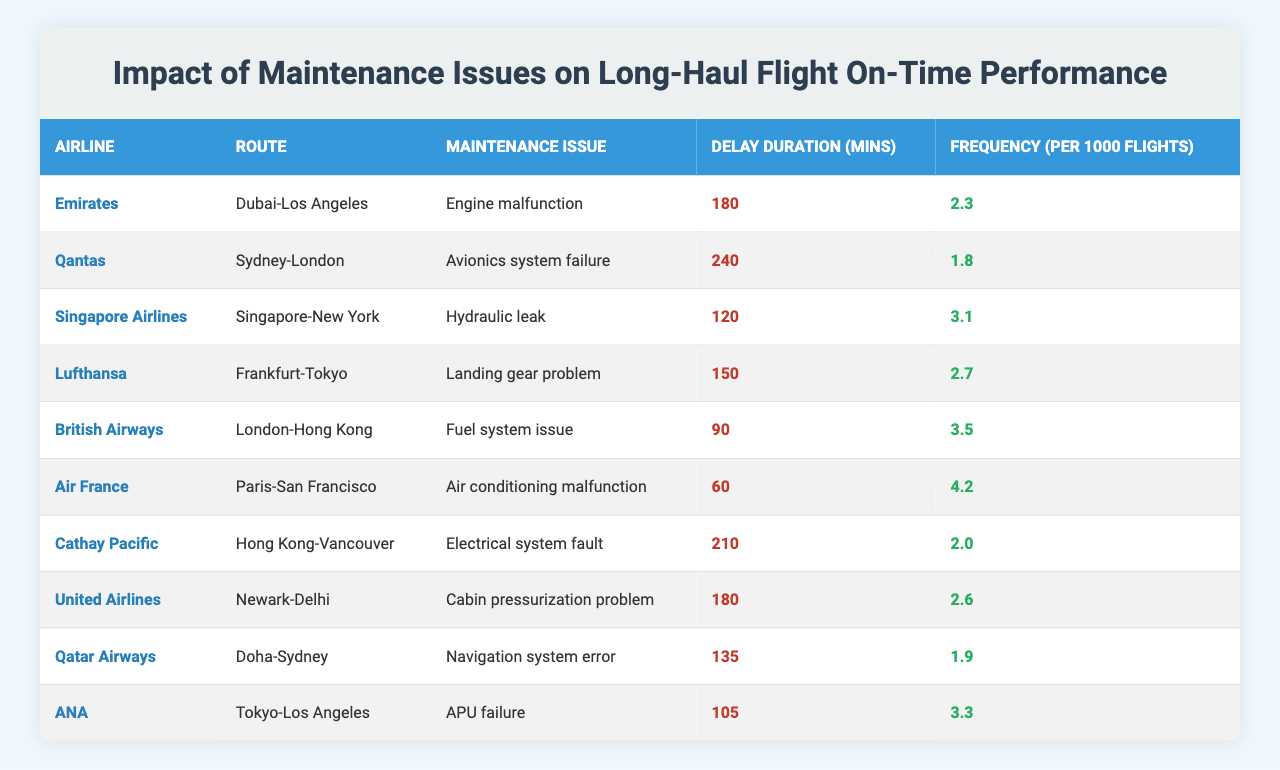What is the longest delay duration in the table? The maximum delay duration can be found by comparing all the values in the "Delay Duration (mins)" column. The maximum value is 240 minutes, which corresponds to Qantas.
Answer: 240 Which airline has the most frequent maintenance issue based on the table? To determine the most frequent maintenance issue, compare the "Frequency (per 1000 flights)" values. The highest value is 4.2 for Air France.
Answer: Air France How many maintenance issues contributed to delays longer than 150 minutes? Count the number of entries in the "Delay Duration (mins)" column that are greater than 150 minutes. The entries for Qantas (240), Emirates (180), and United Airlines (180) contribute to this, totaling three.
Answer: 3 Is there any airline listed that has a fuel system issue? Check the "Maintenance Issue" column for the presence of "Fuel system issue." British Airways has this maintenance issue.
Answer: Yes What is the average delay duration for the airlines in the table? To calculate the average delay, sum all the "Delay Duration (mins)" values (180+240+120+150+90+60+210+180+135+105) to get 1,470 minutes and divide by the number of records (10). Therefore, the average is 1,470/10 = 147 minutes.
Answer: 147 Which airline has the least frequency of maintenance issues recorded? Compare the "Frequency (per 1000 flights)" values to find the lowest. The Aviation issue of Cathay Pacific has the lowest frequency at 2.0.
Answer: Cathay Pacific Are maintenance issues more likely to cause delays above 150 minutes for Emirates compared to others? Check Emirates' delay entry (180 minutes) and compare it with others. Since two other airlines also have delays exceeding 150 minutes, but with a frequency of 1.8 for Qantas it shows that Emirates causes certain delays but not the highest in frequency.
Answer: No What is the total frequency of maintenance issues that resulted in delays for all airlines combined? The total frequency can be calculated by summing the "Frequency (per 1000 flights)" values (2.3 + 1.8 + 3.1 + 2.7 + 3.5 + 4.2 + 2.0 + 2.6 + 1.9 + 3.3) which equals 24.4.
Answer: 24.4 Is the frequency of hydraulic leaks for Singapore Airlines higher than that of the navigation system error for Qatar Airways? Compare the "Frequency (per 1000 flights)" entries for hydraulic leaks (3.1 for Singapore Airlines) and navigation system error (1.9 for Qatar Airways). Since 3.1 is greater than 1.9, Singapore Airlines has a higher frequency.
Answer: Yes What percentage of flights are affected by avionics system failures among the total flights based on the frequency provided? The frequency for Qantas (avionics system failure) is 1.8 per 1000 flights. To convert this to a percentage, (1.8/1000)*100 = 0.18%. This calculates to an effect on 0.18% of flights.
Answer: 0.18% 